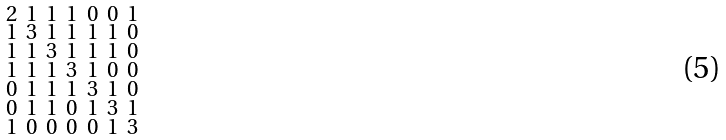<formula> <loc_0><loc_0><loc_500><loc_500>\begin{smallmatrix} 2 & 1 & 1 & 1 & 0 & 0 & 1 \\ 1 & 3 & 1 & 1 & 1 & 1 & 0 \\ 1 & 1 & 3 & 1 & 1 & 1 & 0 \\ 1 & 1 & 1 & 3 & 1 & 0 & 0 \\ 0 & 1 & 1 & 1 & 3 & 1 & 0 \\ 0 & 1 & 1 & 0 & 1 & 3 & 1 \\ 1 & 0 & 0 & 0 & 0 & 1 & 3 \end{smallmatrix}</formula> 